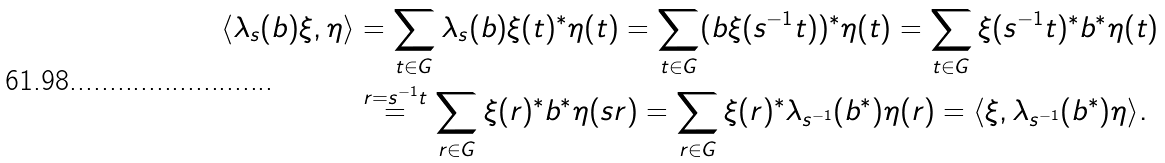Convert formula to latex. <formula><loc_0><loc_0><loc_500><loc_500>\langle \lambda _ { s } ( b ) \xi , \eta \rangle & = \sum _ { t \in G } \lambda _ { s } ( b ) \xi ( t ) ^ { * } \eta ( t ) = \sum _ { t \in G } ( b \xi ( s ^ { - 1 } t ) ) ^ { * } \eta ( t ) = \sum _ { t \in G } \xi ( s ^ { - 1 } t ) ^ { * } b ^ { * } \eta ( t ) \\ & \stackrel { r = s ^ { - 1 } t } { = } \sum _ { r \in G } \xi ( r ) ^ { * } b ^ { * } \eta ( s r ) = \sum _ { r \in G } \xi ( r ) ^ { * } \lambda _ { s ^ { - 1 } } ( b ^ { * } ) \eta ( r ) = \langle \xi , \lambda _ { s ^ { - 1 } } ( b ^ { * } ) \eta \rangle .</formula> 